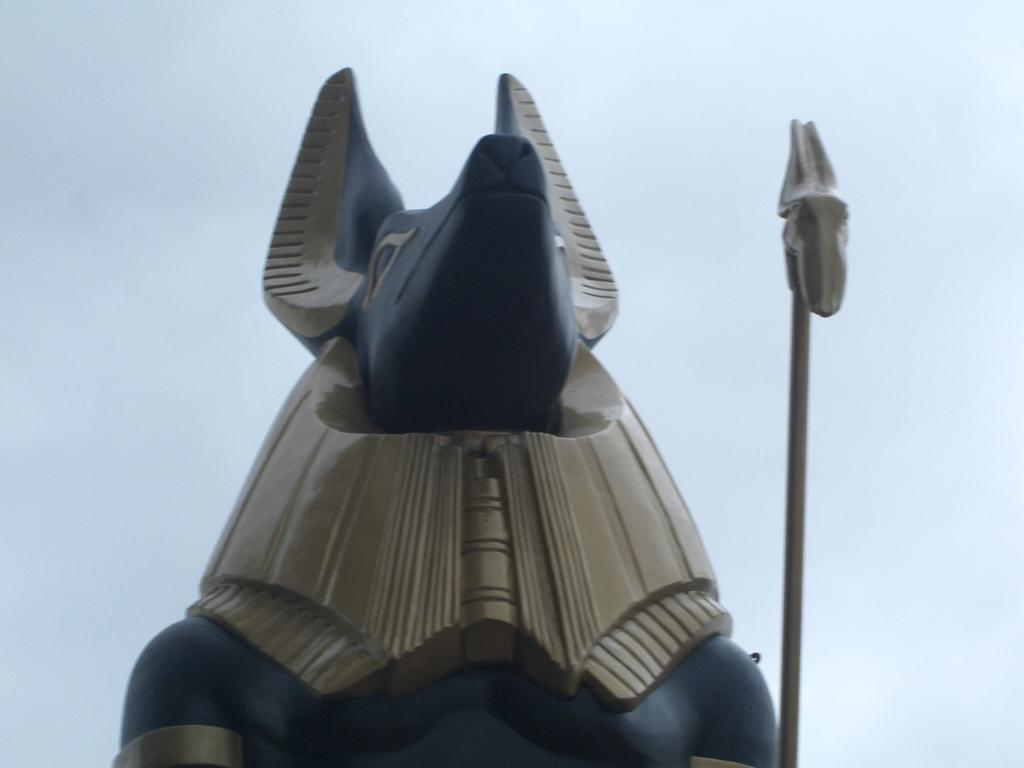What is the main subject in the image? There is a statue in the image. What can be seen in the background of the image? The sky is visible in the background of the image. What sign is displayed on the statue in the image? There is no sign displayed on the statue in the image. 